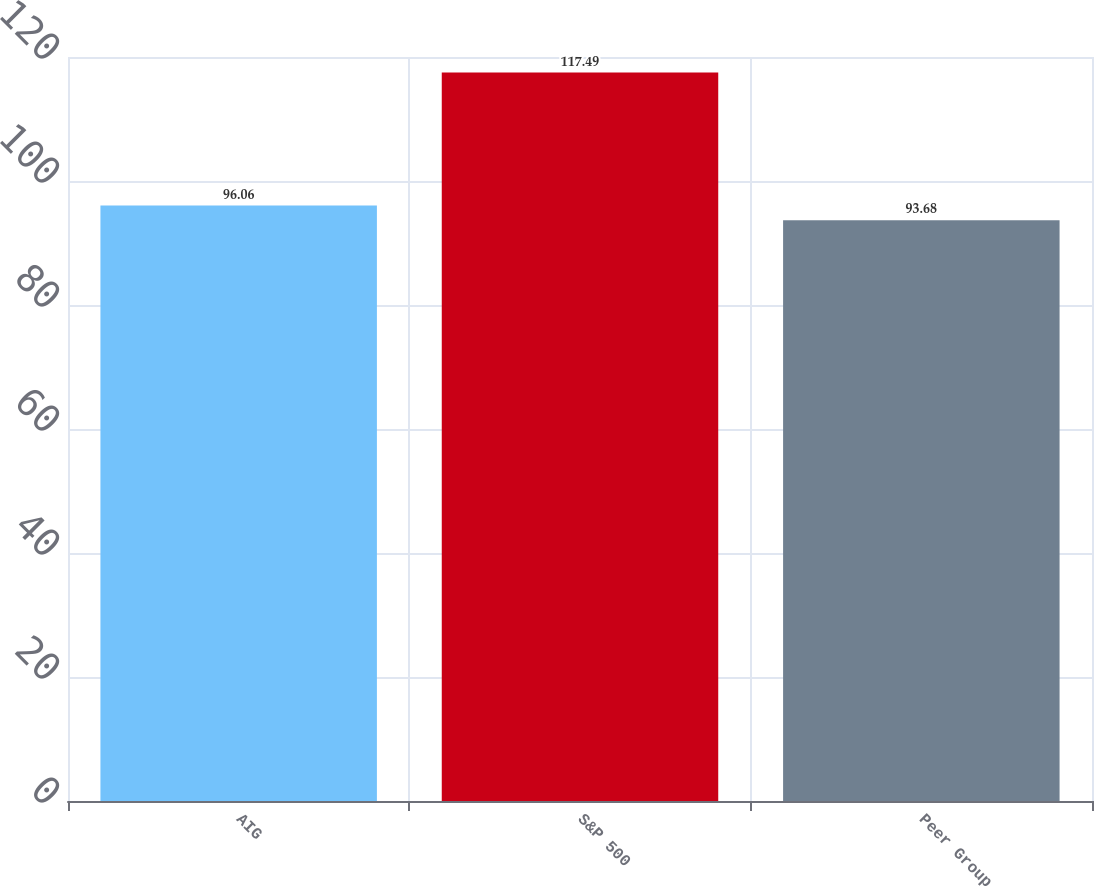Convert chart to OTSL. <chart><loc_0><loc_0><loc_500><loc_500><bar_chart><fcel>AIG<fcel>S&P 500<fcel>Peer Group<nl><fcel>96.06<fcel>117.49<fcel>93.68<nl></chart> 